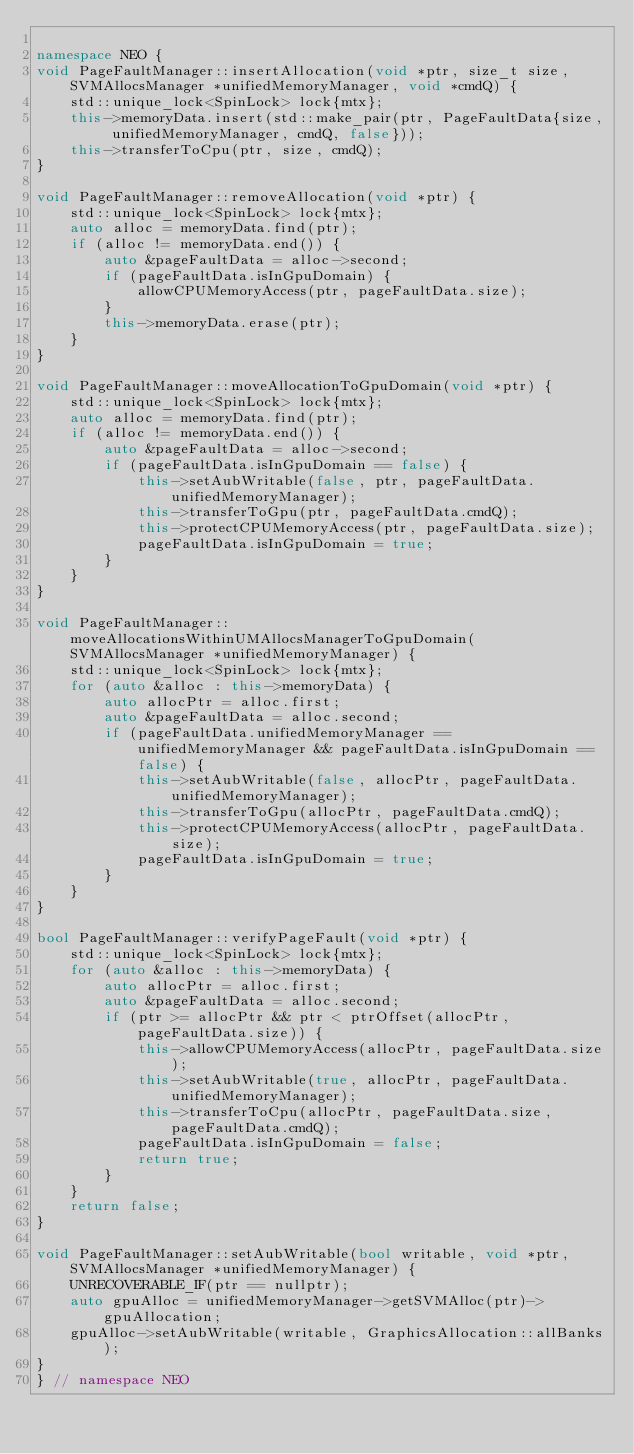Convert code to text. <code><loc_0><loc_0><loc_500><loc_500><_C++_>
namespace NEO {
void PageFaultManager::insertAllocation(void *ptr, size_t size, SVMAllocsManager *unifiedMemoryManager, void *cmdQ) {
    std::unique_lock<SpinLock> lock{mtx};
    this->memoryData.insert(std::make_pair(ptr, PageFaultData{size, unifiedMemoryManager, cmdQ, false}));
    this->transferToCpu(ptr, size, cmdQ);
}

void PageFaultManager::removeAllocation(void *ptr) {
    std::unique_lock<SpinLock> lock{mtx};
    auto alloc = memoryData.find(ptr);
    if (alloc != memoryData.end()) {
        auto &pageFaultData = alloc->second;
        if (pageFaultData.isInGpuDomain) {
            allowCPUMemoryAccess(ptr, pageFaultData.size);
        }
        this->memoryData.erase(ptr);
    }
}

void PageFaultManager::moveAllocationToGpuDomain(void *ptr) {
    std::unique_lock<SpinLock> lock{mtx};
    auto alloc = memoryData.find(ptr);
    if (alloc != memoryData.end()) {
        auto &pageFaultData = alloc->second;
        if (pageFaultData.isInGpuDomain == false) {
            this->setAubWritable(false, ptr, pageFaultData.unifiedMemoryManager);
            this->transferToGpu(ptr, pageFaultData.cmdQ);
            this->protectCPUMemoryAccess(ptr, pageFaultData.size);
            pageFaultData.isInGpuDomain = true;
        }
    }
}

void PageFaultManager::moveAllocationsWithinUMAllocsManagerToGpuDomain(SVMAllocsManager *unifiedMemoryManager) {
    std::unique_lock<SpinLock> lock{mtx};
    for (auto &alloc : this->memoryData) {
        auto allocPtr = alloc.first;
        auto &pageFaultData = alloc.second;
        if (pageFaultData.unifiedMemoryManager == unifiedMemoryManager && pageFaultData.isInGpuDomain == false) {
            this->setAubWritable(false, allocPtr, pageFaultData.unifiedMemoryManager);
            this->transferToGpu(allocPtr, pageFaultData.cmdQ);
            this->protectCPUMemoryAccess(allocPtr, pageFaultData.size);
            pageFaultData.isInGpuDomain = true;
        }
    }
}

bool PageFaultManager::verifyPageFault(void *ptr) {
    std::unique_lock<SpinLock> lock{mtx};
    for (auto &alloc : this->memoryData) {
        auto allocPtr = alloc.first;
        auto &pageFaultData = alloc.second;
        if (ptr >= allocPtr && ptr < ptrOffset(allocPtr, pageFaultData.size)) {
            this->allowCPUMemoryAccess(allocPtr, pageFaultData.size);
            this->setAubWritable(true, allocPtr, pageFaultData.unifiedMemoryManager);
            this->transferToCpu(allocPtr, pageFaultData.size, pageFaultData.cmdQ);
            pageFaultData.isInGpuDomain = false;
            return true;
        }
    }
    return false;
}

void PageFaultManager::setAubWritable(bool writable, void *ptr, SVMAllocsManager *unifiedMemoryManager) {
    UNRECOVERABLE_IF(ptr == nullptr);
    auto gpuAlloc = unifiedMemoryManager->getSVMAlloc(ptr)->gpuAllocation;
    gpuAlloc->setAubWritable(writable, GraphicsAllocation::allBanks);
}
} // namespace NEO
</code> 